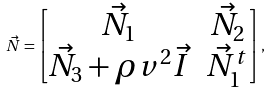<formula> <loc_0><loc_0><loc_500><loc_500>\vec { N } = \begin{bmatrix} \vec { N } _ { 1 } & \vec { N } _ { 2 } \\ \vec { N } _ { 3 } + \rho v ^ { 2 } \vec { I } & \vec { N } _ { 1 } ^ { t } \end{bmatrix} ,</formula> 